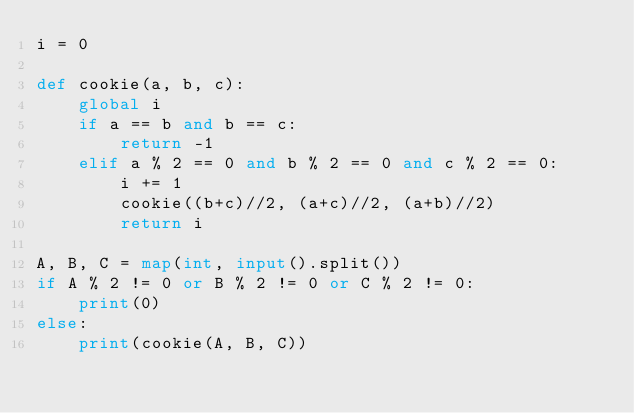<code> <loc_0><loc_0><loc_500><loc_500><_Python_>i = 0

def cookie(a, b, c):
    global i
    if a == b and b == c:
        return -1
    elif a % 2 == 0 and b % 2 == 0 and c % 2 == 0:
        i += 1
        cookie((b+c)//2, (a+c)//2, (a+b)//2)
        return i

A, B, C = map(int, input().split())
if A % 2 != 0 or B % 2 != 0 or C % 2 != 0:
    print(0)
else:
    print(cookie(A, B, C))</code> 